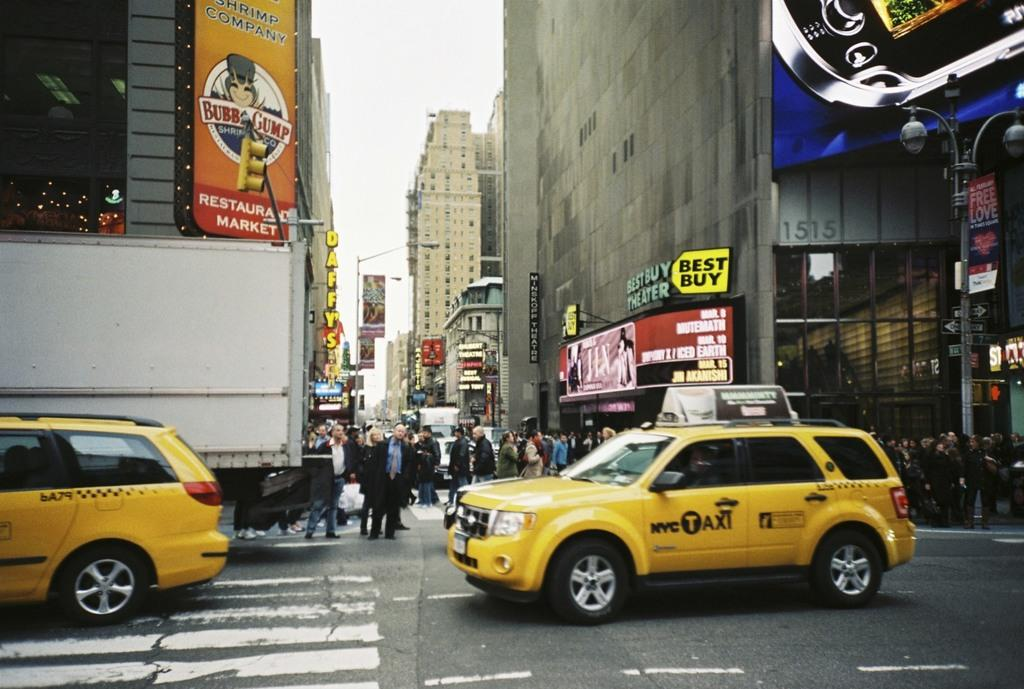<image>
Relay a brief, clear account of the picture shown. Two SUV NYC Taxi cabs are traveling on a busing street. 